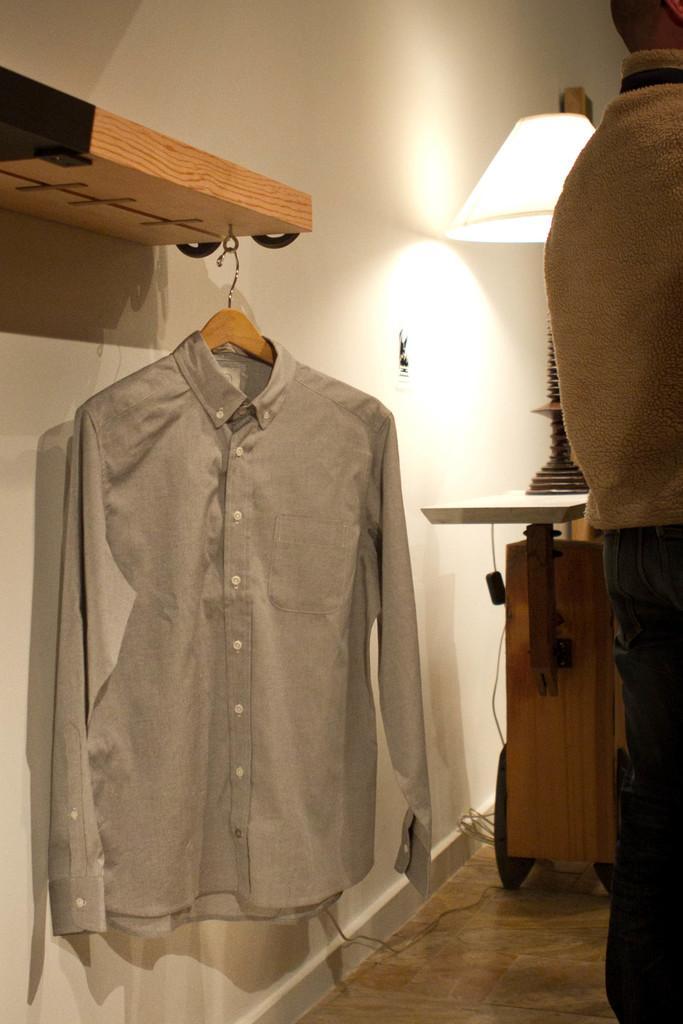Could you give a brief overview of what you see in this image? In this given image, I can see a person standing and a light and i can see a wall which is colored with light cream color and i can see a shirt hanging to a wooden wood which is attached to the wall. 